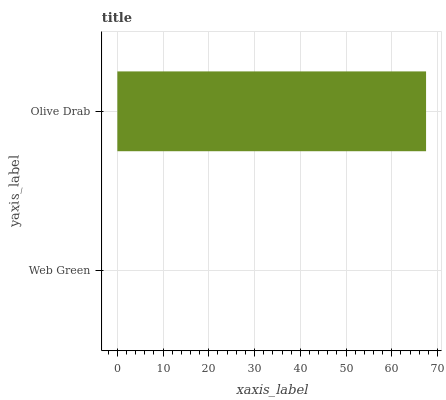Is Web Green the minimum?
Answer yes or no. Yes. Is Olive Drab the maximum?
Answer yes or no. Yes. Is Olive Drab the minimum?
Answer yes or no. No. Is Olive Drab greater than Web Green?
Answer yes or no. Yes. Is Web Green less than Olive Drab?
Answer yes or no. Yes. Is Web Green greater than Olive Drab?
Answer yes or no. No. Is Olive Drab less than Web Green?
Answer yes or no. No. Is Olive Drab the high median?
Answer yes or no. Yes. Is Web Green the low median?
Answer yes or no. Yes. Is Web Green the high median?
Answer yes or no. No. Is Olive Drab the low median?
Answer yes or no. No. 